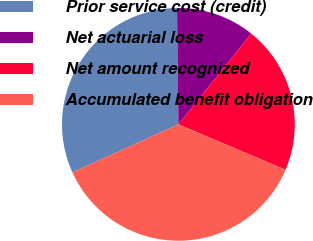Convert chart. <chart><loc_0><loc_0><loc_500><loc_500><pie_chart><fcel>Prior service cost (credit)<fcel>Net actuarial loss<fcel>Net amount recognized<fcel>Accumulated benefit obligation<nl><fcel>31.58%<fcel>10.96%<fcel>20.61%<fcel>36.84%<nl></chart> 